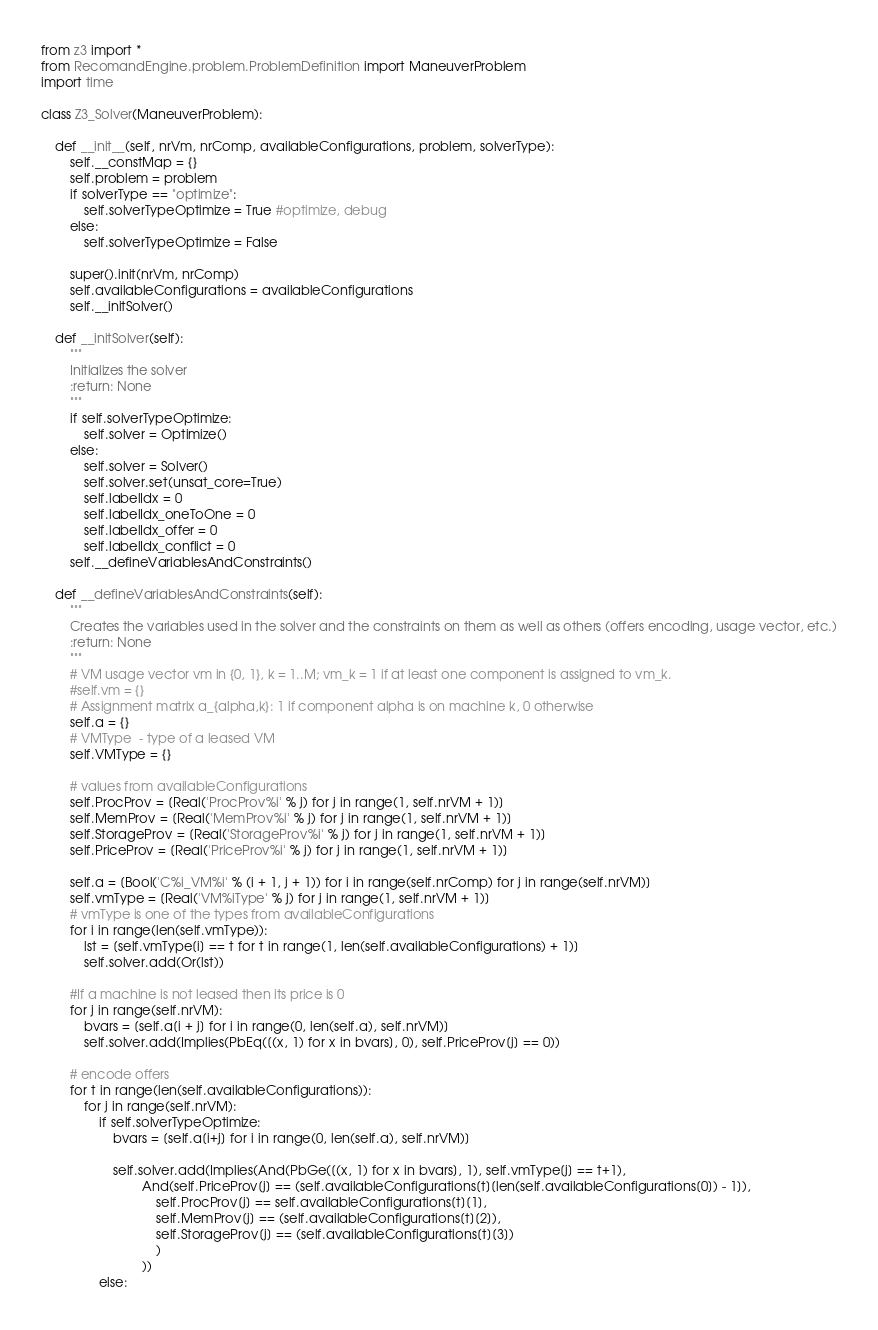<code> <loc_0><loc_0><loc_500><loc_500><_Python_>from z3 import *
from RecomandEngine.problem.ProblemDefinition import ManeuverProblem
import time

class Z3_Solver(ManeuverProblem):

    def __init__(self, nrVm, nrComp, availableConfigurations, problem, solverType):
        self.__constMap = {}
        self.problem = problem
        if solverType == "optimize":
            self.solverTypeOptimize = True #optimize, debug
        else:
            self.solverTypeOptimize = False

        super().init(nrVm, nrComp)
        self.availableConfigurations = availableConfigurations
        self.__initSolver()

    def __initSolver(self):
        """
        Initializes the solver
        :return: None
        """
        if self.solverTypeOptimize:
            self.solver = Optimize()
        else:
            self.solver = Solver()
            self.solver.set(unsat_core=True)
            self.labelIdx = 0
            self.labelIdx_oneToOne = 0
            self.labelIdx_offer = 0
            self.labelIdx_conflict = 0
        self.__defineVariablesAndConstraints()

    def __defineVariablesAndConstraints(self):
        """
        Creates the variables used in the solver and the constraints on them as well as others (offers encoding, usage vector, etc.)
        :return: None
        """
        # VM usage vector vm in {0, 1}, k = 1..M; vm_k = 1 if at least one component is assigned to vm_k.
        #self.vm = {}
        # Assignment matrix a_{alpha,k}: 1 if component alpha is on machine k, 0 otherwise
        self.a = {}
        # VMType  - type of a leased VM
        self.VMType = {}

        # values from availableConfigurations
        self.ProcProv = [Real('ProcProv%i' % j) for j in range(1, self.nrVM + 1)]
        self.MemProv = [Real('MemProv%i' % j) for j in range(1, self.nrVM + 1)]
        self.StorageProv = [Real('StorageProv%i' % j) for j in range(1, self.nrVM + 1)]
        self.PriceProv = [Real('PriceProv%i' % j) for j in range(1, self.nrVM + 1)]

        self.a = [Bool('C%i_VM%i' % (i + 1, j + 1)) for i in range(self.nrComp) for j in range(self.nrVM)]
        self.vmType = [Real('VM%iType' % j) for j in range(1, self.nrVM + 1)]
        # vmType is one of the types from availableConfigurations
        for i in range(len(self.vmType)):
            lst = [self.vmType[i] == t for t in range(1, len(self.availableConfigurations) + 1)]
            self.solver.add(Or(lst))

        #If a machine is not leased then its price is 0
        for j in range(self.nrVM):
            bvars = [self.a[i + j] for i in range(0, len(self.a), self.nrVM)]
            self.solver.add(Implies(PbEq([(x, 1) for x in bvars], 0), self.PriceProv[j] == 0))

        # encode offers
        for t in range(len(self.availableConfigurations)):
            for j in range(self.nrVM):
                if self.solverTypeOptimize:
                    bvars = [self.a[i+j] for i in range(0, len(self.a), self.nrVM)]

                    self.solver.add(Implies(And(PbGe([(x, 1) for x in bvars], 1), self.vmType[j] == t+1),
                            And(self.PriceProv[j] == (self.availableConfigurations[t][len(self.availableConfigurations[0]) - 1]),
                                self.ProcProv[j] == self.availableConfigurations[t][1],
                                self.MemProv[j] == (self.availableConfigurations[t][2]),
                                self.StorageProv[j] == (self.availableConfigurations[t][3])
                                )
                            ))
                else:</code> 